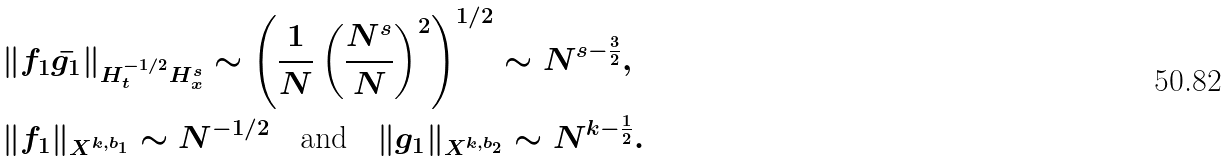<formula> <loc_0><loc_0><loc_500><loc_500>& \| f _ { 1 } \bar { g _ { 1 } } \| _ { H _ { t } ^ { - 1 / 2 } H _ { x } ^ { s } } \sim \left ( \frac { 1 } { N } \left ( \frac { N ^ { s } } { N } \right ) ^ { 2 } \right ) ^ { 1 / 2 } \sim N ^ { s - \frac { 3 } { 2 } } , \\ & \| f _ { 1 } \| _ { X ^ { k , b _ { 1 } } } \sim N ^ { - 1 / 2 } \quad \text {and} \quad \| g _ { 1 } \| _ { X ^ { k , b _ { 2 } } } \sim N ^ { k - \frac { 1 } { 2 } } .</formula> 